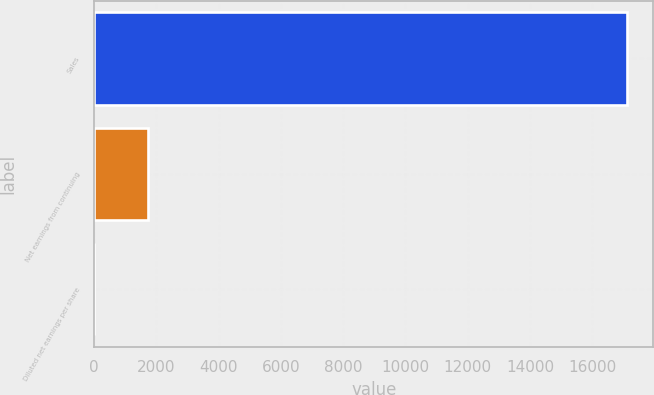Convert chart. <chart><loc_0><loc_0><loc_500><loc_500><bar_chart><fcel>Sales<fcel>Net earnings from continuing<fcel>Diluted net earnings per share<nl><fcel>17107.3<fcel>1712.85<fcel>2.35<nl></chart> 